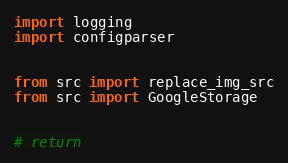<code> <loc_0><loc_0><loc_500><loc_500><_Python_>import logging
import configparser


from src import replace_img_src
from src import GoogleStorage


# return</code> 